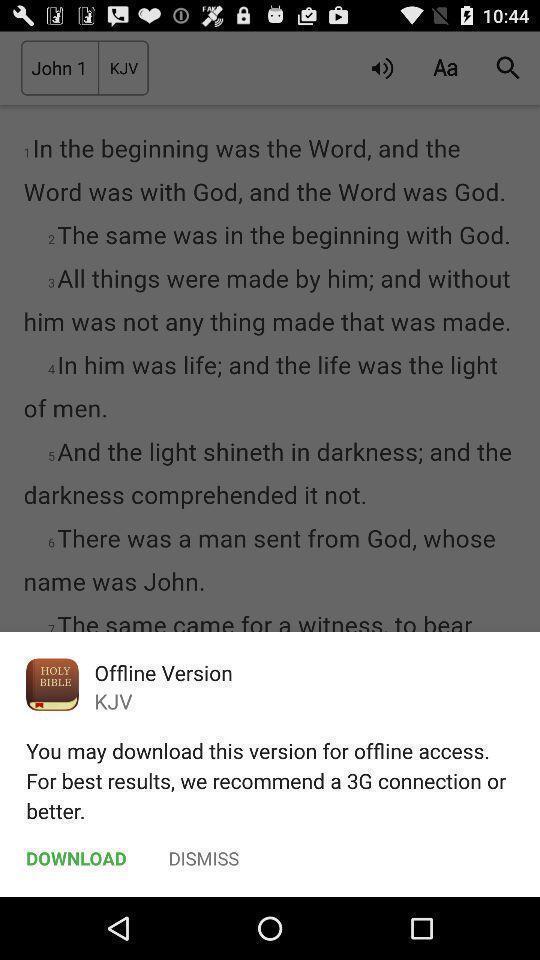Tell me what you see in this picture. Pop-up showing the download option for offline version. 